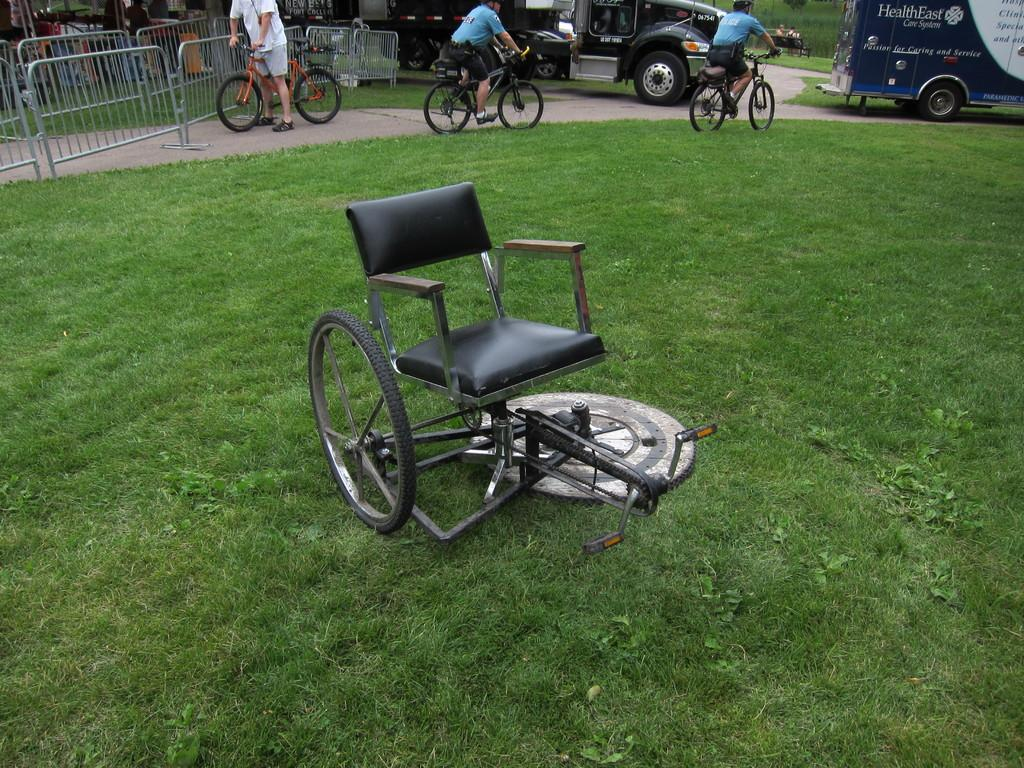What type of wheelchair is shown in the image? There is a wheelchair with a pedal system in the image. What is the surface on which the wheelchair is placed? The wheelchair is on a grass surface. What are the men in the background of the image doing? Each man is holding a bicycle. What type of cap is the man in the image wearing? There is no man wearing a cap in the image; the focus is on the wheelchair and the men holding bicycles in the background. 